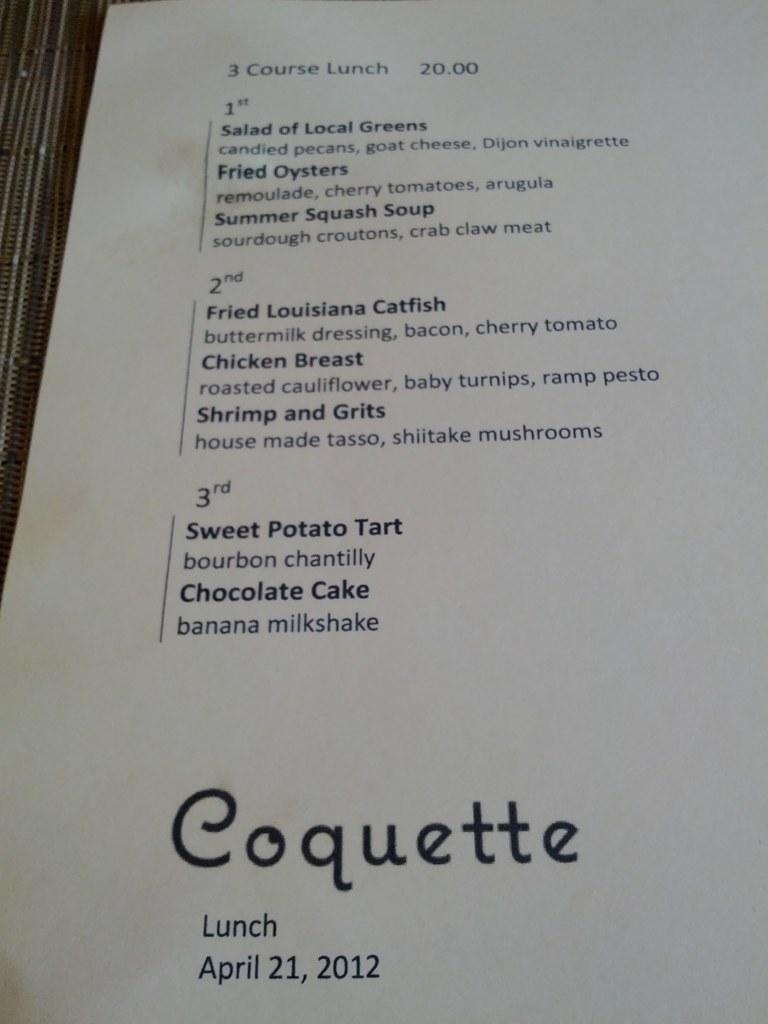<image>
Provide a brief description of the given image. A Coquette restaurant lunch menu from April 21st, 2012. 